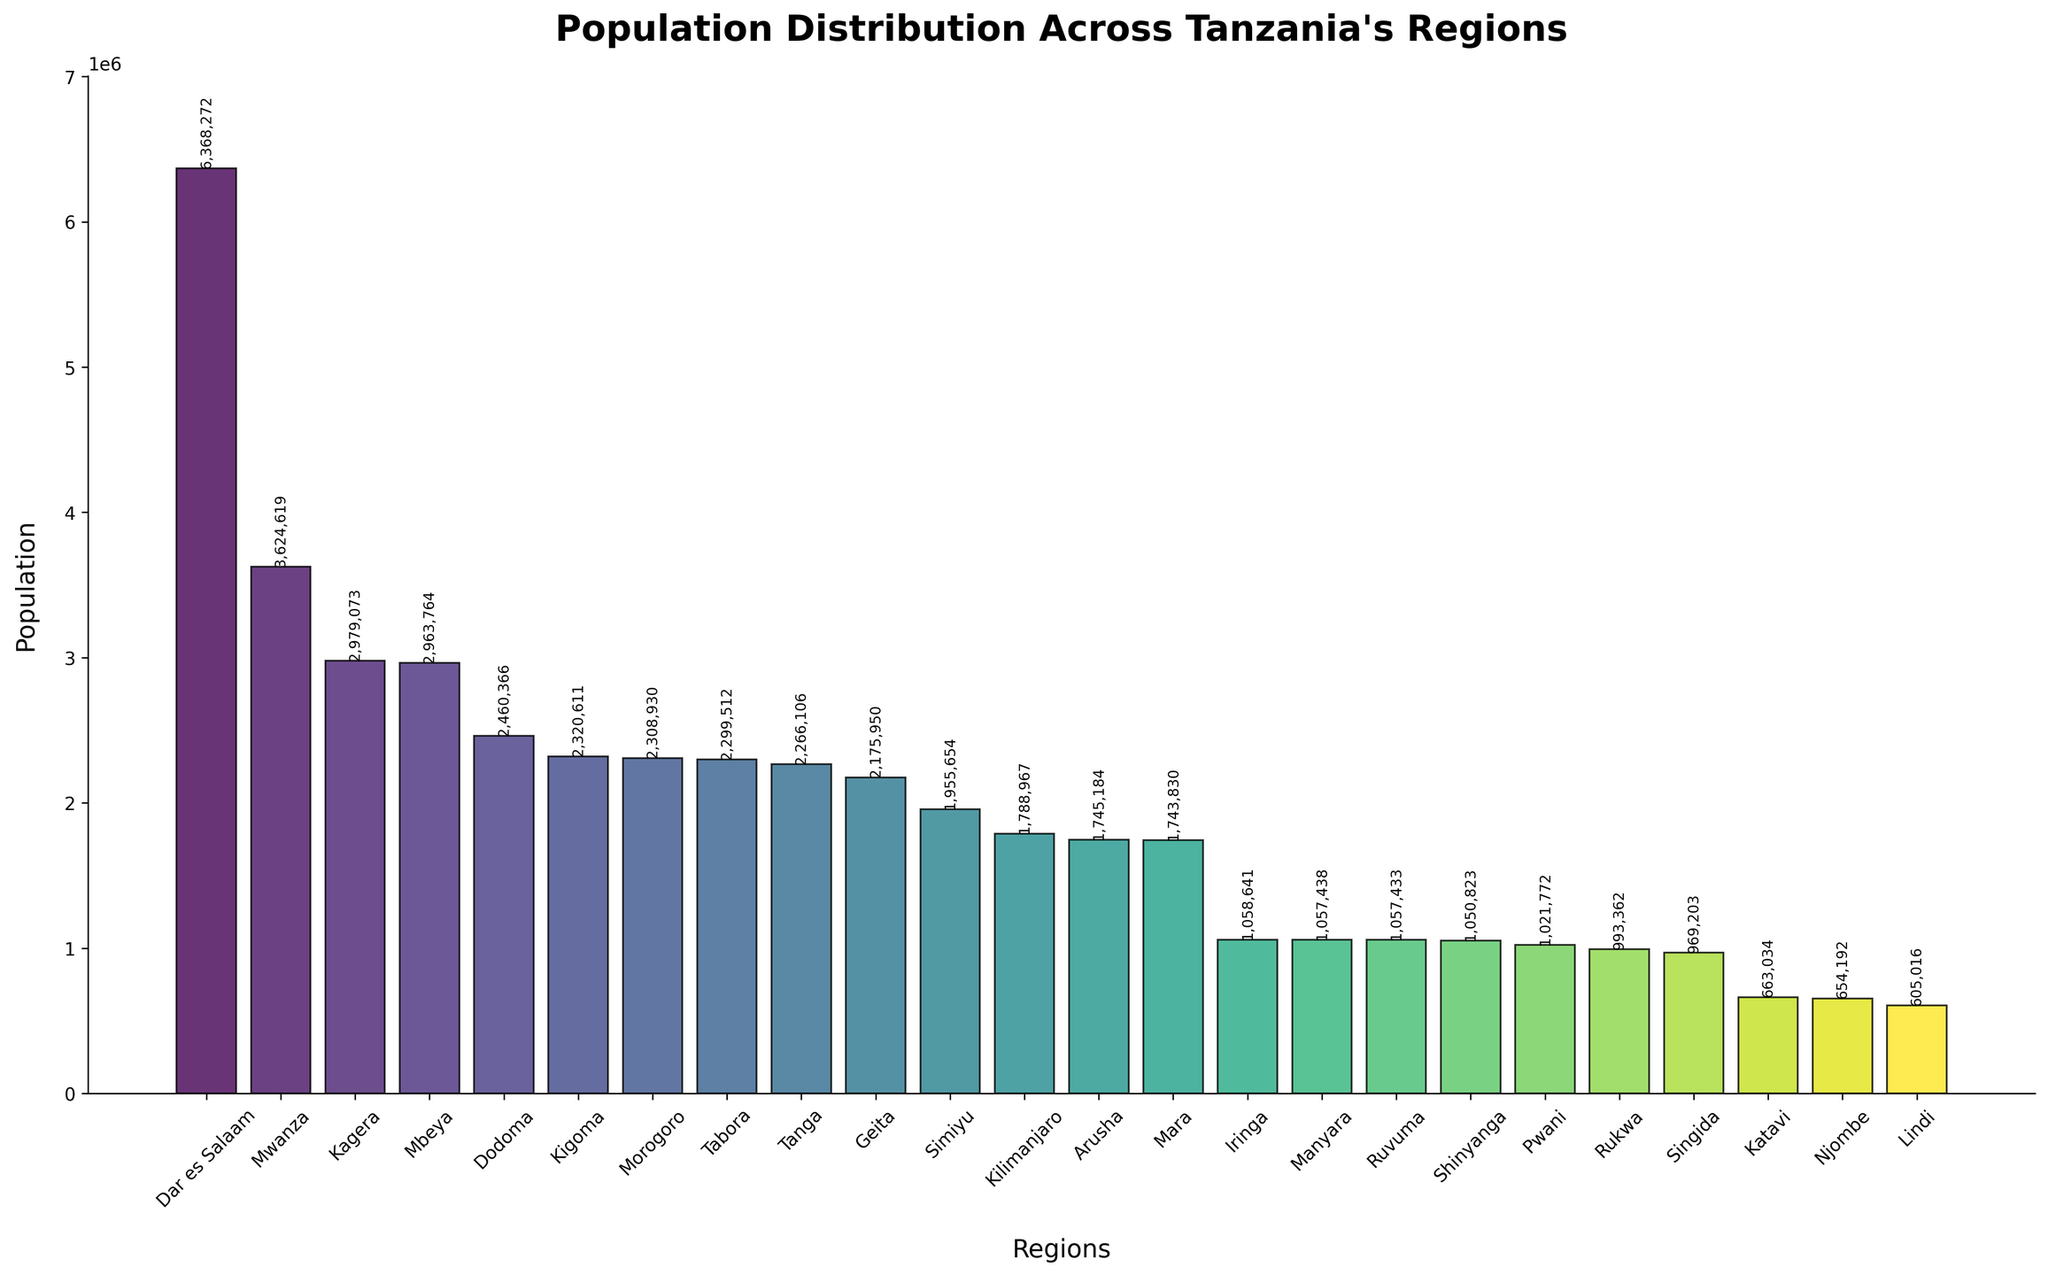Which region has the highest population? The bar representing Dar es Salaam is visually the tallest among all regions.
Answer: Dar es Salaam How does the population of Mwanza compare to Arusha? The bar for Mwanza is taller than the bar for Arusha, indicating that Mwanza has a higher population.
Answer: Mwanza has a higher population Is the population of Kilimanjaro greater than or less than Iringa? The bar for Kilimanjaro is taller than the bar for Iringa, showing that Kilimanjaro has a greater population.
Answer: Greater What is the combined population of Dodoma and Tabora based on the chart? Add the populations of Dodoma (2,460,366) and Tabora (2,299,512).
Answer: 4,759,878 Which region's population is closest to 2,000,000 based on the visual inspection? The bar representing Geita is the closest to 2,000,000, being slightly above that mark.
Answer: Geita Compare the population of Kigoma to that of Tanga. The bars for Kigoma and Tanga are nearly the same height, but Kigoma's is slightly higher, indicating a marginally higher population.
Answer: Kigoma is slightly higher What is the population difference between Mbeya and Kagera? Subtract the population of Kagera (2,979,073) from Mbeya (2,963,764).
Answer: 16,701 Identify the regions with populations under 1 million. The bars for Katavi, Njombe, and Lindi are below the 1 million mark.
Answer: Katavi, Njombe, Lindi What is the average population of the three regions with the least populations? Add the populations of Katavi (663,034), Njombe (654,192), and Lindi (605,016), then divide by 3.
Answer: 640,747.33 Which region has a population just above 1 million? The bar representing Pwani has a population slightly above the 1 million mark.
Answer: Pwani 